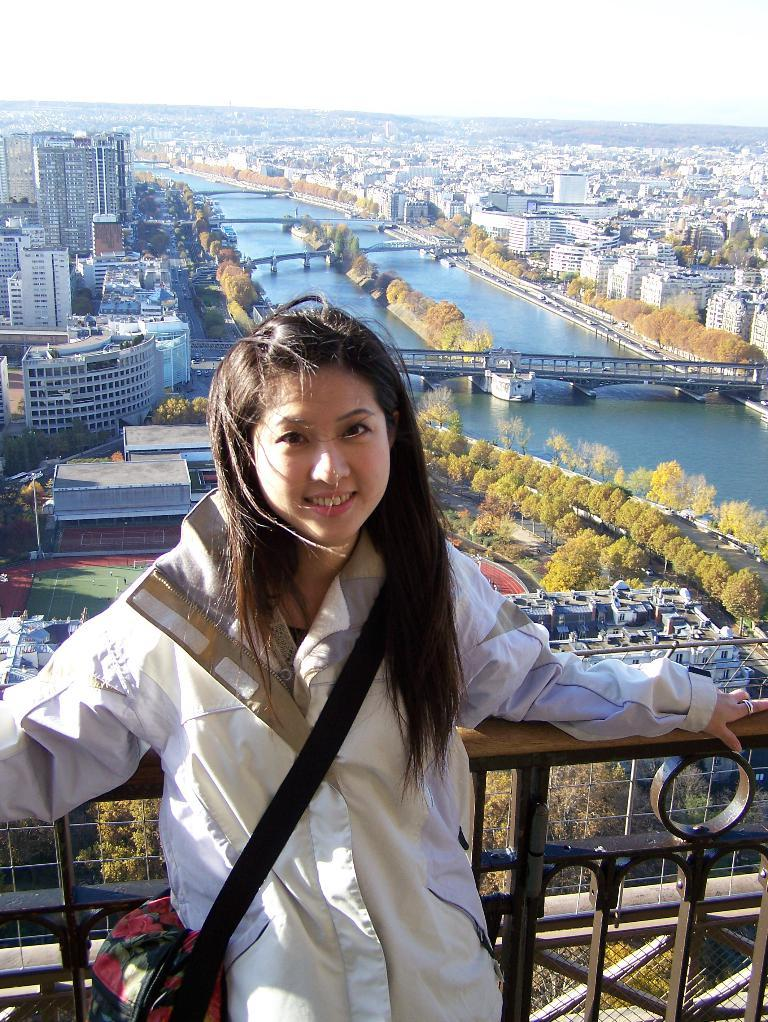Who is present in the image? There is a woman in the image. What is the woman doing in the image? The woman is leaning on a railing. What can be seen in the background of the image? There are buildings, trees, a lake, bridges, and the sky visible in the background of the image. What type of pain is the woman experiencing in the image? There is no indication in the image that the woman is experiencing any pain. 